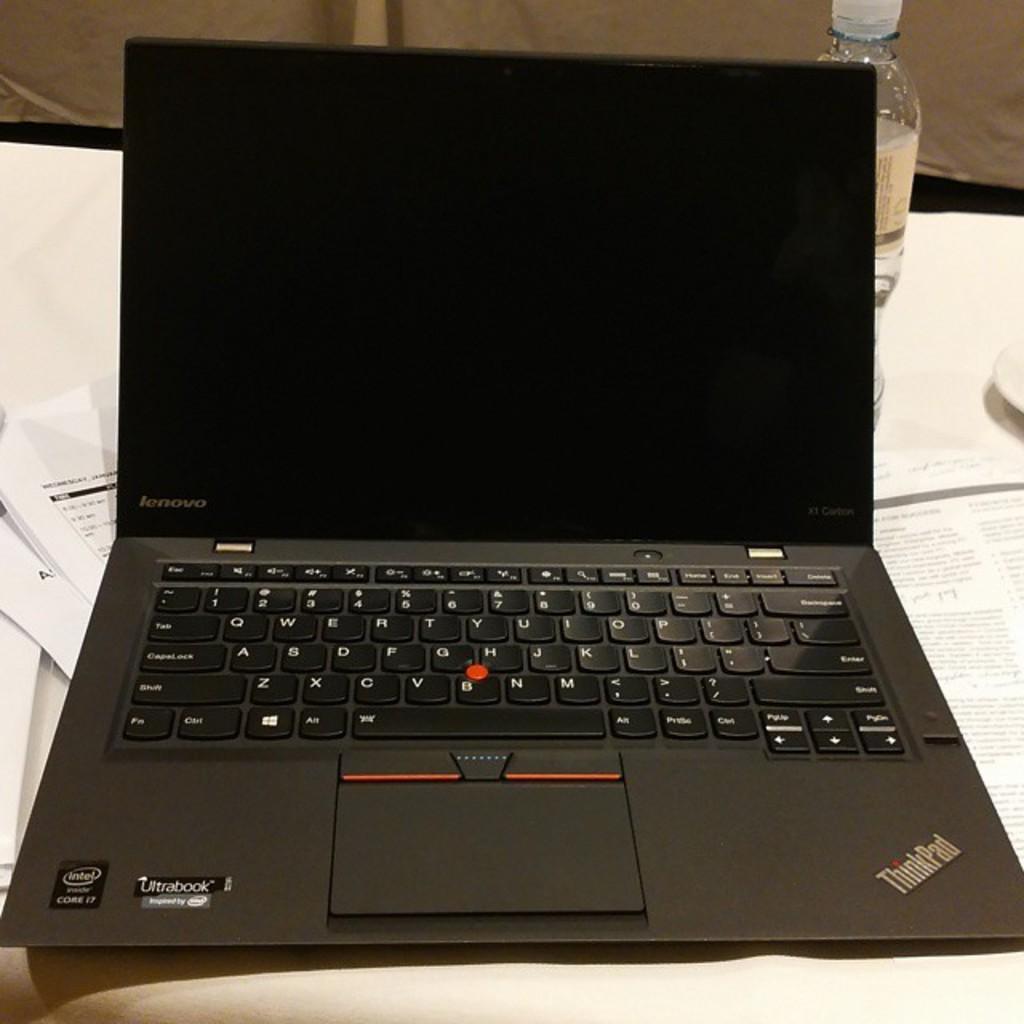What brand of laptop?
Provide a succinct answer. Lenovo. What is on the bottom right on the laptop?
Your response must be concise. Thinkpad. 